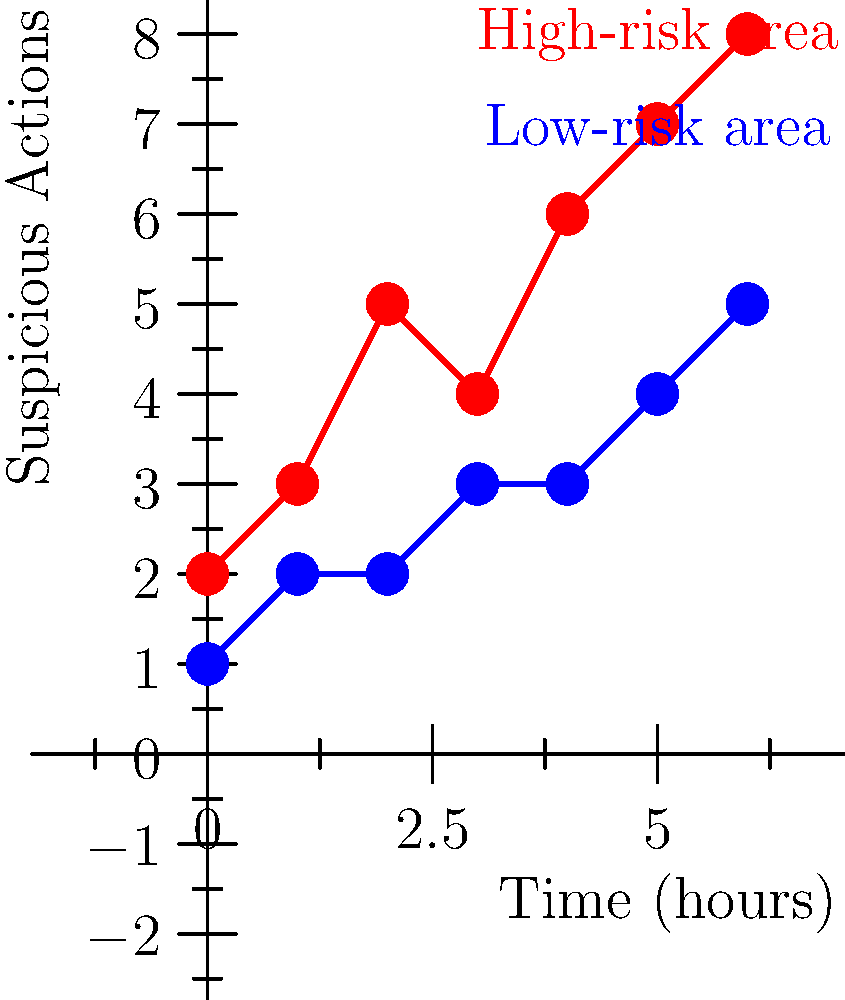As a crime novelist investigating patterns in surveillance footage, you've plotted suspicious actions over time in two different areas of a children's park. Based on the graph, what conclusion can you draw about the potential risk to children's safety, and how might this inform your advocacy work? To analyze this graph and draw conclusions about potential risks to children's safety, let's follow these steps:

1. Interpret the graph:
   - The x-axis represents time in hours.
   - The y-axis represents the number of suspicious actions observed.
   - The red line represents data from a high-risk area.
   - The blue line represents data from a low-risk area.

2. Compare the two areas:
   - The high-risk area (red) consistently shows more suspicious actions than the low-risk area (blue).
   - The gap between the two areas widens over time.

3. Analyze the trends:
   - Both areas show an increasing trend in suspicious actions over time.
   - The high-risk area's increase is steeper, indicating a faster rise in suspicious activities.

4. Calculate the rate of increase:
   - High-risk area: $(8-2)/6 = 1$ suspicious action per hour
   - Low-risk area: $(5-1)/6 = 0.67$ suspicious actions per hour

5. Assess the potential risk:
   - The high-risk area shows a higher baseline of suspicious activities and a faster increase over time.
   - This suggests a greater potential risk to children's safety in the high-risk area.

6. Implications for advocacy work:
   - Focus on increased surveillance and security measures in the high-risk area.
   - Implement preventive measures to address the rising trend in both areas.
   - Use this data to support calls for increased resources for children's safety in public spaces.

Conclusion: The data indicates a higher and faster-growing risk in the designated high-risk area, necessitating immediate attention and targeted interventions to ensure children's safety.
Answer: Higher, faster-growing risk in high-risk area; prioritize interventions there while addressing overall increasing trends. 